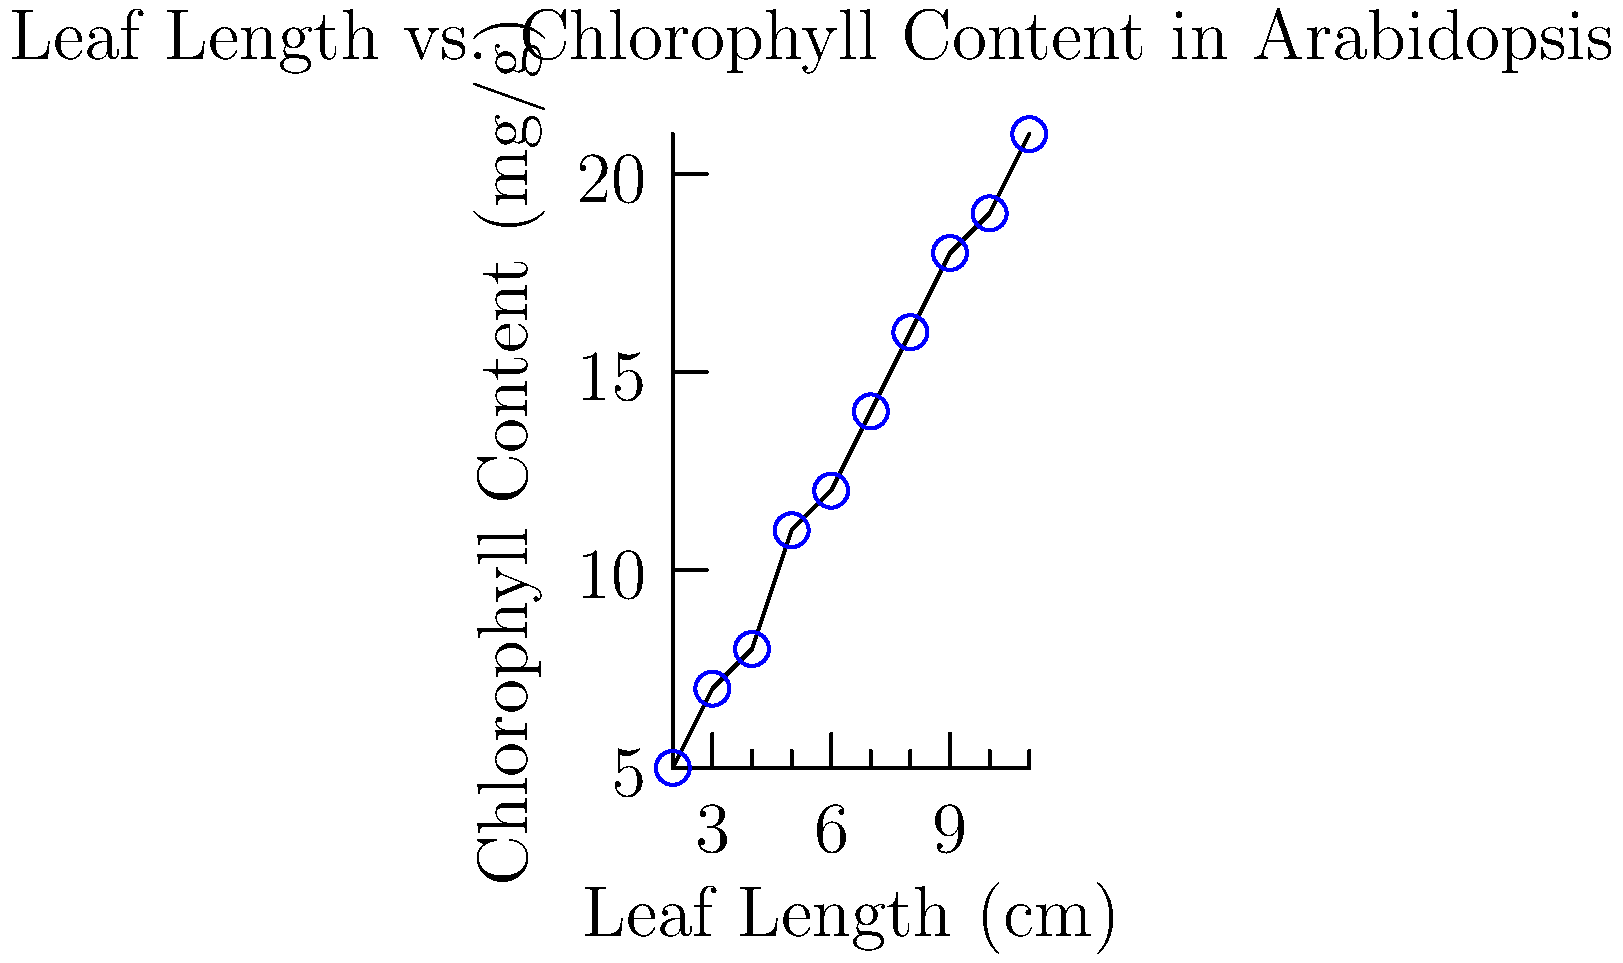The scatter plot shows the relationship between leaf length and chlorophyll content in Arabidopsis thaliana plants. Based on the data presented, calculate the Pearson correlation coefficient (r) to determine the strength and direction of the relationship between these two traits. Round your answer to two decimal places. To calculate the Pearson correlation coefficient (r), we'll follow these steps:

1. Calculate the means of x (leaf length) and y (chlorophyll content):
   $\bar{x} = \frac{\sum x}{n} = \frac{65}{10} = 6.5$
   $\bar{y} = \frac{\sum y}{n} = \frac{131}{10} = 13.1$

2. Calculate the deviations from the mean for both x and y.

3. Calculate the products of the deviations and their sum:
   $\sum (x - \bar{x})(y - \bar{y}) = 148.5$

4. Calculate the sum of squared deviations for x and y:
   $\sum (x - \bar{x})^2 = 82.5$
   $\sum (y - \bar{y})^2 = 270.9$

5. Apply the formula for Pearson's r:
   $$r = \frac{\sum (x - \bar{x})(y - \bar{y})}{\sqrt{\sum (x - \bar{x})^2 \sum (y - \bar{y})^2}}$$

6. Plug in the values:
   $$r = \frac{148.5}{\sqrt{82.5 \times 270.9}} = \frac{148.5}{\sqrt{22349.25}} = \frac{148.5}{149.5} \approx 0.9933$$

7. Round to two decimal places: 0.99

The Pearson correlation coefficient of 0.99 indicates a very strong positive linear relationship between leaf length and chlorophyll content in the Arabidopsis plants studied.
Answer: 0.99 